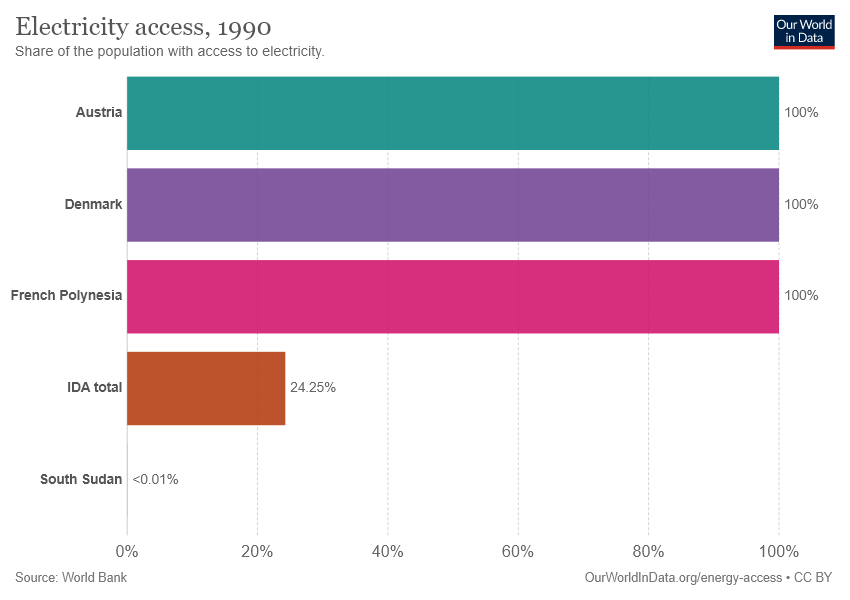List a handful of essential elements in this visual. The two bars in question, Denmark and French Polynesia, have the same value. 